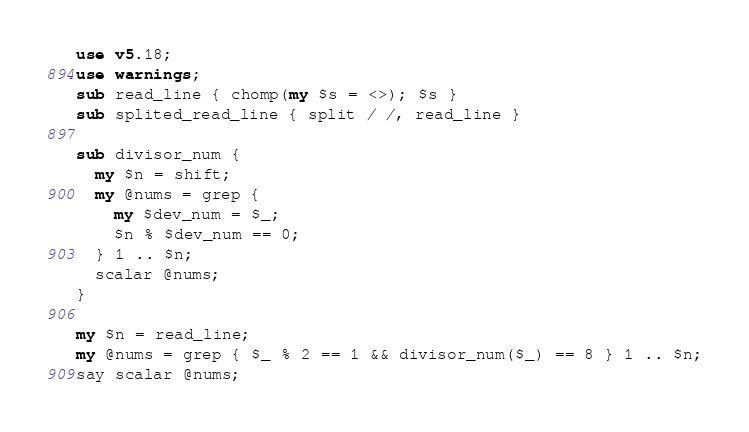<code> <loc_0><loc_0><loc_500><loc_500><_Perl_>use v5.18;
use warnings;
sub read_line { chomp(my $s = <>); $s }
sub splited_read_line { split / /, read_line }

sub divisor_num {
  my $n = shift;
  my @nums = grep {
    my $dev_num = $_;
    $n % $dev_num == 0;
  } 1 .. $n;
  scalar @nums;
}

my $n = read_line;
my @nums = grep { $_ % 2 == 1 && divisor_num($_) == 8 } 1 .. $n;
say scalar @nums;
</code> 